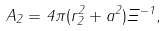<formula> <loc_0><loc_0><loc_500><loc_500>A _ { 2 } = 4 \pi ( r ^ { 2 } _ { 2 } + a ^ { 2 } ) \Xi ^ { - 1 } ,</formula> 